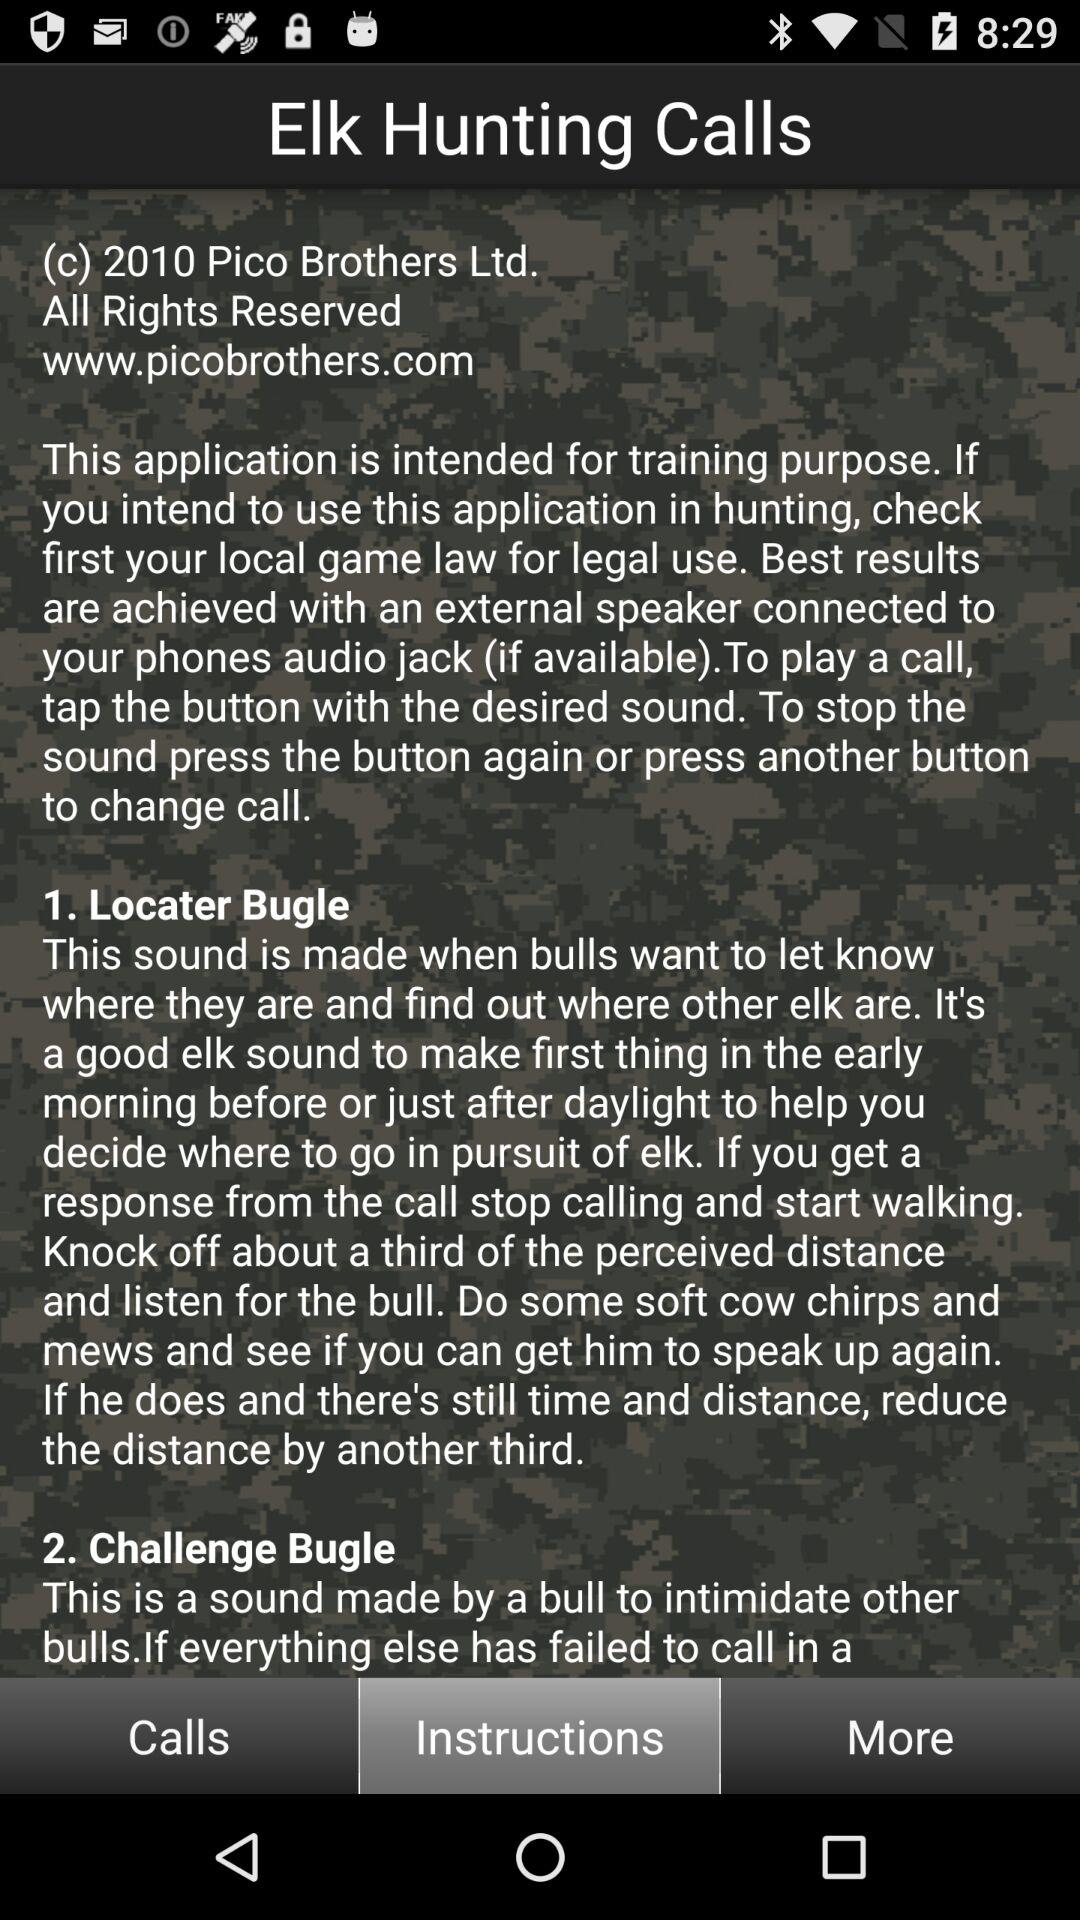What is the name of the application? The name of the application is "EIk Hunting Calls". 